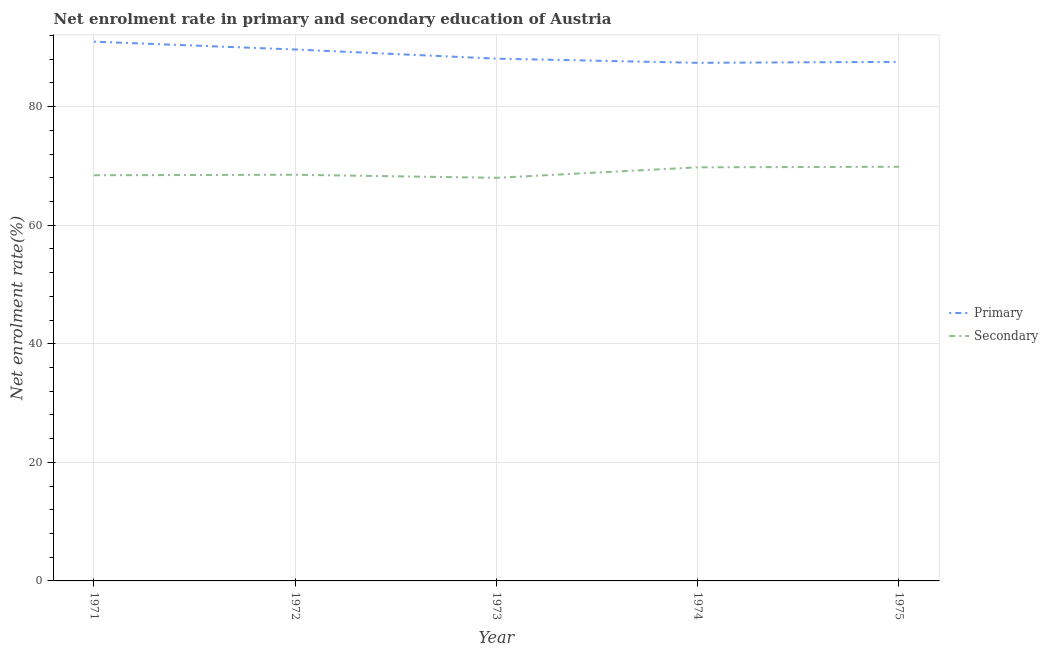How many different coloured lines are there?
Your answer should be compact. 2. What is the enrollment rate in primary education in 1975?
Make the answer very short. 87.55. Across all years, what is the maximum enrollment rate in secondary education?
Offer a very short reply. 69.86. Across all years, what is the minimum enrollment rate in primary education?
Offer a very short reply. 87.39. In which year was the enrollment rate in secondary education maximum?
Your response must be concise. 1975. What is the total enrollment rate in secondary education in the graph?
Your answer should be very brief. 344.56. What is the difference between the enrollment rate in secondary education in 1972 and that in 1974?
Give a very brief answer. -1.26. What is the difference between the enrollment rate in secondary education in 1975 and the enrollment rate in primary education in 1973?
Ensure brevity in your answer.  -18.24. What is the average enrollment rate in primary education per year?
Give a very brief answer. 88.73. In the year 1975, what is the difference between the enrollment rate in secondary education and enrollment rate in primary education?
Provide a succinct answer. -17.69. In how many years, is the enrollment rate in secondary education greater than 56 %?
Offer a very short reply. 5. What is the ratio of the enrollment rate in primary education in 1971 to that in 1975?
Your response must be concise. 1.04. Is the difference between the enrollment rate in primary education in 1972 and 1975 greater than the difference between the enrollment rate in secondary education in 1972 and 1975?
Offer a terse response. Yes. What is the difference between the highest and the second highest enrollment rate in secondary education?
Keep it short and to the point. 0.09. What is the difference between the highest and the lowest enrollment rate in primary education?
Ensure brevity in your answer.  3.57. In how many years, is the enrollment rate in primary education greater than the average enrollment rate in primary education taken over all years?
Provide a short and direct response. 2. Does the enrollment rate in secondary education monotonically increase over the years?
Your answer should be very brief. No. Is the enrollment rate in secondary education strictly less than the enrollment rate in primary education over the years?
Offer a very short reply. Yes. How many years are there in the graph?
Ensure brevity in your answer.  5. What is the difference between two consecutive major ticks on the Y-axis?
Offer a very short reply. 20. Where does the legend appear in the graph?
Give a very brief answer. Center right. How many legend labels are there?
Provide a succinct answer. 2. How are the legend labels stacked?
Your answer should be compact. Vertical. What is the title of the graph?
Make the answer very short. Net enrolment rate in primary and secondary education of Austria. What is the label or title of the Y-axis?
Offer a very short reply. Net enrolment rate(%). What is the Net enrolment rate(%) of Primary in 1971?
Your answer should be very brief. 90.96. What is the Net enrolment rate(%) in Secondary in 1971?
Keep it short and to the point. 68.43. What is the Net enrolment rate(%) of Primary in 1972?
Your answer should be very brief. 89.64. What is the Net enrolment rate(%) of Secondary in 1972?
Provide a succinct answer. 68.51. What is the Net enrolment rate(%) of Primary in 1973?
Give a very brief answer. 88.1. What is the Net enrolment rate(%) of Secondary in 1973?
Your answer should be very brief. 68. What is the Net enrolment rate(%) of Primary in 1974?
Keep it short and to the point. 87.39. What is the Net enrolment rate(%) in Secondary in 1974?
Give a very brief answer. 69.77. What is the Net enrolment rate(%) of Primary in 1975?
Provide a short and direct response. 87.55. What is the Net enrolment rate(%) in Secondary in 1975?
Provide a succinct answer. 69.86. Across all years, what is the maximum Net enrolment rate(%) of Primary?
Provide a short and direct response. 90.96. Across all years, what is the maximum Net enrolment rate(%) of Secondary?
Offer a terse response. 69.86. Across all years, what is the minimum Net enrolment rate(%) of Primary?
Offer a very short reply. 87.39. Across all years, what is the minimum Net enrolment rate(%) in Secondary?
Give a very brief answer. 68. What is the total Net enrolment rate(%) of Primary in the graph?
Your answer should be very brief. 443.64. What is the total Net enrolment rate(%) in Secondary in the graph?
Make the answer very short. 344.56. What is the difference between the Net enrolment rate(%) of Primary in 1971 and that in 1972?
Your response must be concise. 1.32. What is the difference between the Net enrolment rate(%) of Secondary in 1971 and that in 1972?
Your response must be concise. -0.08. What is the difference between the Net enrolment rate(%) of Primary in 1971 and that in 1973?
Keep it short and to the point. 2.86. What is the difference between the Net enrolment rate(%) of Secondary in 1971 and that in 1973?
Provide a succinct answer. 0.43. What is the difference between the Net enrolment rate(%) in Primary in 1971 and that in 1974?
Your response must be concise. 3.57. What is the difference between the Net enrolment rate(%) in Secondary in 1971 and that in 1974?
Offer a very short reply. -1.34. What is the difference between the Net enrolment rate(%) of Primary in 1971 and that in 1975?
Provide a succinct answer. 3.41. What is the difference between the Net enrolment rate(%) of Secondary in 1971 and that in 1975?
Provide a short and direct response. -1.43. What is the difference between the Net enrolment rate(%) of Primary in 1972 and that in 1973?
Your answer should be very brief. 1.54. What is the difference between the Net enrolment rate(%) in Secondary in 1972 and that in 1973?
Offer a terse response. 0.51. What is the difference between the Net enrolment rate(%) in Primary in 1972 and that in 1974?
Make the answer very short. 2.25. What is the difference between the Net enrolment rate(%) of Secondary in 1972 and that in 1974?
Keep it short and to the point. -1.26. What is the difference between the Net enrolment rate(%) in Primary in 1972 and that in 1975?
Keep it short and to the point. 2.09. What is the difference between the Net enrolment rate(%) in Secondary in 1972 and that in 1975?
Your answer should be compact. -1.35. What is the difference between the Net enrolment rate(%) in Primary in 1973 and that in 1974?
Your answer should be compact. 0.71. What is the difference between the Net enrolment rate(%) of Secondary in 1973 and that in 1974?
Your response must be concise. -1.77. What is the difference between the Net enrolment rate(%) of Primary in 1973 and that in 1975?
Ensure brevity in your answer.  0.54. What is the difference between the Net enrolment rate(%) in Secondary in 1973 and that in 1975?
Provide a short and direct response. -1.86. What is the difference between the Net enrolment rate(%) of Primary in 1974 and that in 1975?
Give a very brief answer. -0.16. What is the difference between the Net enrolment rate(%) in Secondary in 1974 and that in 1975?
Offer a very short reply. -0.09. What is the difference between the Net enrolment rate(%) of Primary in 1971 and the Net enrolment rate(%) of Secondary in 1972?
Offer a very short reply. 22.45. What is the difference between the Net enrolment rate(%) of Primary in 1971 and the Net enrolment rate(%) of Secondary in 1973?
Make the answer very short. 22.96. What is the difference between the Net enrolment rate(%) of Primary in 1971 and the Net enrolment rate(%) of Secondary in 1974?
Keep it short and to the point. 21.19. What is the difference between the Net enrolment rate(%) of Primary in 1971 and the Net enrolment rate(%) of Secondary in 1975?
Make the answer very short. 21.1. What is the difference between the Net enrolment rate(%) in Primary in 1972 and the Net enrolment rate(%) in Secondary in 1973?
Your response must be concise. 21.64. What is the difference between the Net enrolment rate(%) in Primary in 1972 and the Net enrolment rate(%) in Secondary in 1974?
Offer a very short reply. 19.87. What is the difference between the Net enrolment rate(%) of Primary in 1972 and the Net enrolment rate(%) of Secondary in 1975?
Ensure brevity in your answer.  19.78. What is the difference between the Net enrolment rate(%) in Primary in 1973 and the Net enrolment rate(%) in Secondary in 1974?
Offer a terse response. 18.33. What is the difference between the Net enrolment rate(%) in Primary in 1973 and the Net enrolment rate(%) in Secondary in 1975?
Make the answer very short. 18.24. What is the difference between the Net enrolment rate(%) of Primary in 1974 and the Net enrolment rate(%) of Secondary in 1975?
Make the answer very short. 17.53. What is the average Net enrolment rate(%) of Primary per year?
Your response must be concise. 88.73. What is the average Net enrolment rate(%) of Secondary per year?
Ensure brevity in your answer.  68.91. In the year 1971, what is the difference between the Net enrolment rate(%) in Primary and Net enrolment rate(%) in Secondary?
Provide a succinct answer. 22.53. In the year 1972, what is the difference between the Net enrolment rate(%) of Primary and Net enrolment rate(%) of Secondary?
Offer a very short reply. 21.13. In the year 1973, what is the difference between the Net enrolment rate(%) of Primary and Net enrolment rate(%) of Secondary?
Give a very brief answer. 20.1. In the year 1974, what is the difference between the Net enrolment rate(%) in Primary and Net enrolment rate(%) in Secondary?
Give a very brief answer. 17.62. In the year 1975, what is the difference between the Net enrolment rate(%) of Primary and Net enrolment rate(%) of Secondary?
Ensure brevity in your answer.  17.69. What is the ratio of the Net enrolment rate(%) of Primary in 1971 to that in 1972?
Keep it short and to the point. 1.01. What is the ratio of the Net enrolment rate(%) of Secondary in 1971 to that in 1972?
Ensure brevity in your answer.  1. What is the ratio of the Net enrolment rate(%) in Primary in 1971 to that in 1973?
Give a very brief answer. 1.03. What is the ratio of the Net enrolment rate(%) of Secondary in 1971 to that in 1973?
Provide a succinct answer. 1.01. What is the ratio of the Net enrolment rate(%) in Primary in 1971 to that in 1974?
Offer a terse response. 1.04. What is the ratio of the Net enrolment rate(%) in Secondary in 1971 to that in 1974?
Provide a succinct answer. 0.98. What is the ratio of the Net enrolment rate(%) of Primary in 1971 to that in 1975?
Give a very brief answer. 1.04. What is the ratio of the Net enrolment rate(%) in Secondary in 1971 to that in 1975?
Offer a very short reply. 0.98. What is the ratio of the Net enrolment rate(%) of Primary in 1972 to that in 1973?
Provide a short and direct response. 1.02. What is the ratio of the Net enrolment rate(%) of Secondary in 1972 to that in 1973?
Your answer should be compact. 1.01. What is the ratio of the Net enrolment rate(%) of Primary in 1972 to that in 1974?
Make the answer very short. 1.03. What is the ratio of the Net enrolment rate(%) of Primary in 1972 to that in 1975?
Ensure brevity in your answer.  1.02. What is the ratio of the Net enrolment rate(%) in Secondary in 1972 to that in 1975?
Your answer should be compact. 0.98. What is the ratio of the Net enrolment rate(%) in Primary in 1973 to that in 1974?
Give a very brief answer. 1.01. What is the ratio of the Net enrolment rate(%) of Secondary in 1973 to that in 1974?
Offer a very short reply. 0.97. What is the ratio of the Net enrolment rate(%) in Primary in 1973 to that in 1975?
Ensure brevity in your answer.  1.01. What is the ratio of the Net enrolment rate(%) of Secondary in 1973 to that in 1975?
Make the answer very short. 0.97. What is the ratio of the Net enrolment rate(%) in Primary in 1974 to that in 1975?
Give a very brief answer. 1. What is the ratio of the Net enrolment rate(%) of Secondary in 1974 to that in 1975?
Provide a succinct answer. 1. What is the difference between the highest and the second highest Net enrolment rate(%) of Primary?
Provide a short and direct response. 1.32. What is the difference between the highest and the second highest Net enrolment rate(%) of Secondary?
Your answer should be very brief. 0.09. What is the difference between the highest and the lowest Net enrolment rate(%) in Primary?
Make the answer very short. 3.57. What is the difference between the highest and the lowest Net enrolment rate(%) of Secondary?
Your answer should be compact. 1.86. 